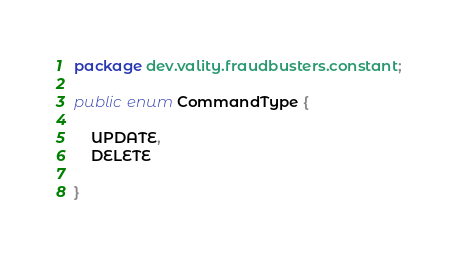<code> <loc_0><loc_0><loc_500><loc_500><_Java_>package dev.vality.fraudbusters.constant;

public enum CommandType {

    UPDATE,
    DELETE

}
</code> 